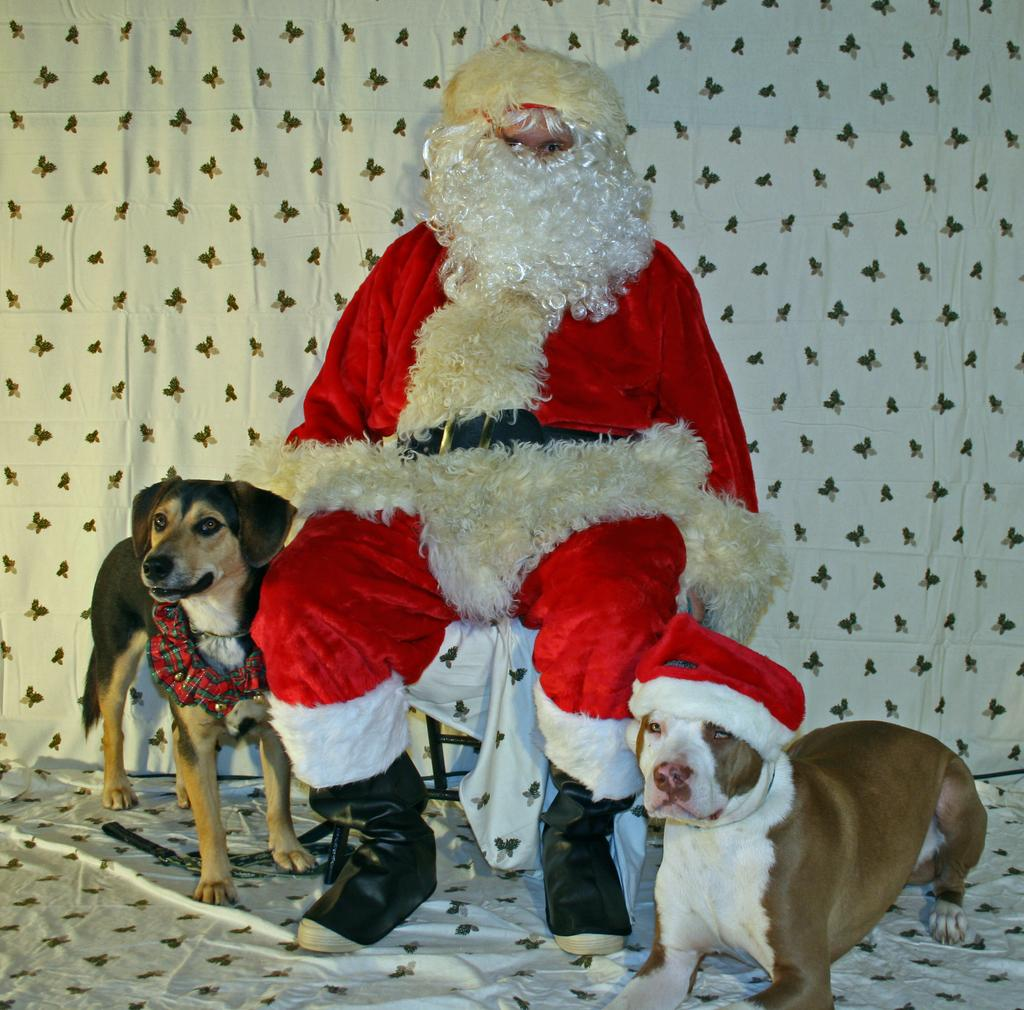Who is present in the image? There is a person in the image. What is the person wearing? The person is wearing a fancy dress. What is the person doing in the image? The person is sitting on a chair. What animals are present in the image? There are dogs on the left and right side of the person. What can be seen behind the person? There is a cloth visible behind the person. What type of unit is being measured in the image? There is no indication of any unit being measured in the image. What songs are being sung by the person in the image? There is no indication of any singing or songs in the image. 